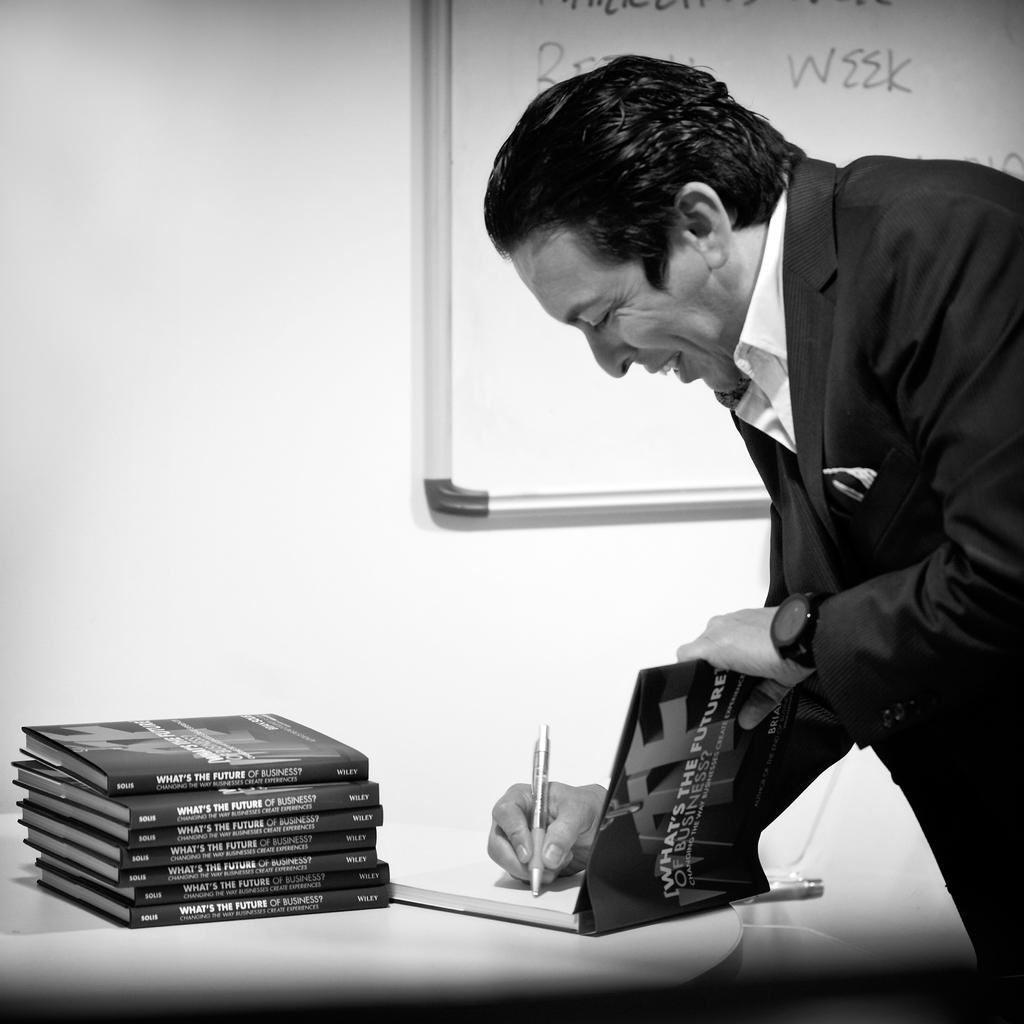<image>
Summarize the visual content of the image. A man signing a book titled What's The Future of Business. 